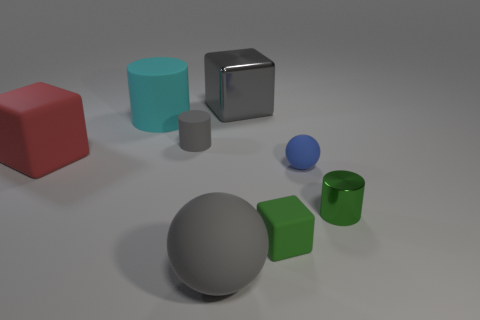Add 1 large balls. How many objects exist? 9 Subtract all cylinders. How many objects are left? 5 Subtract 0 cyan blocks. How many objects are left? 8 Subtract all gray cylinders. Subtract all green metallic things. How many objects are left? 6 Add 6 metallic cubes. How many metallic cubes are left? 7 Add 3 large yellow rubber cylinders. How many large yellow rubber cylinders exist? 3 